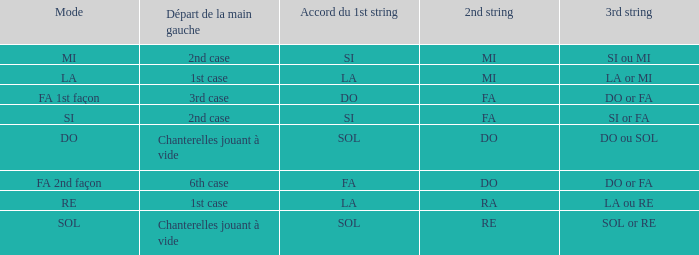For the 2nd string of Ra what is the Depart de la main gauche? 1st case. 